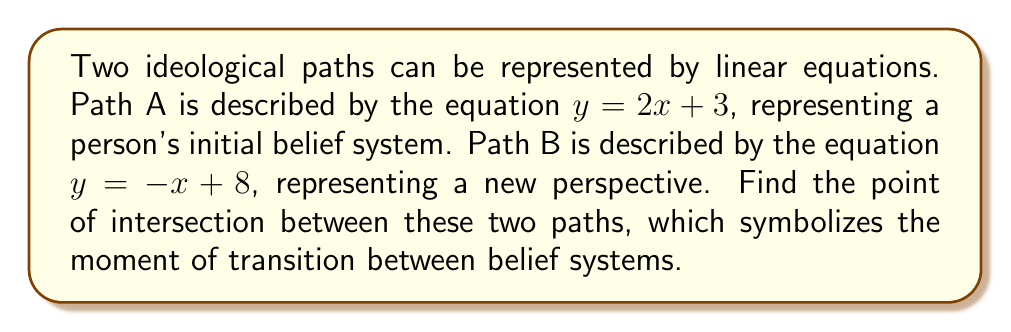Could you help me with this problem? To find the intersection point of these two ideological paths, we need to solve the system of equations:

1) First, let's write out our system of equations:
   $$\begin{cases}
   y = 2x + 3 \\
   y = -x + 8
   \end{cases}$$

2) Since both equations are equal to y, we can set them equal to each other:
   $$2x + 3 = -x + 8$$

3) Now, let's solve for x:
   $$2x + 3 = -x + 8$$
   $$3x = 5$$
   $$x = \frac{5}{3}$$

4) Now that we know x, we can substitute this value into either of the original equations to find y. Let's use the first equation:
   $$y = 2(\frac{5}{3}) + 3$$
   $$y = \frac{10}{3} + 3$$
   $$y = \frac{10}{3} + \frac{9}{3}$$
   $$y = \frac{19}{3}$$

5) Therefore, the point of intersection is $(\frac{5}{3}, \frac{19}{3})$.

This point represents the moment in the belief transition where the old and new ideologies intersect.
Answer: $(\frac{5}{3}, \frac{19}{3})$ 